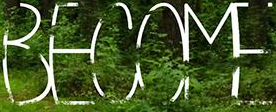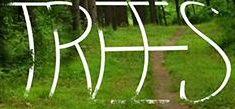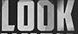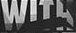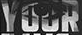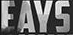Read the text content from these images in order, separated by a semicolon. BECOME; TREES; LOOK; WITH; YOUR; EAYS 